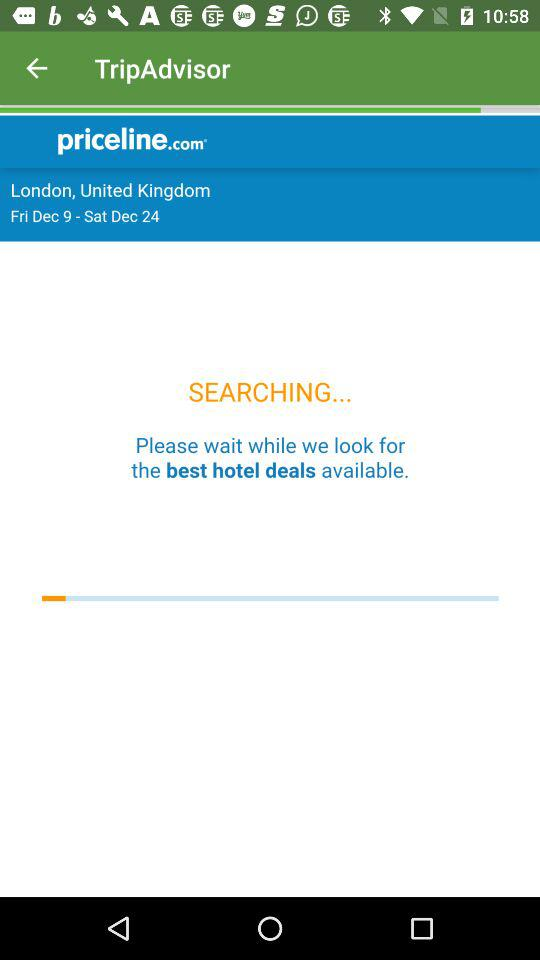For what locations are hotels being searched? The hotels in London, United Kingdom, are being searched. 